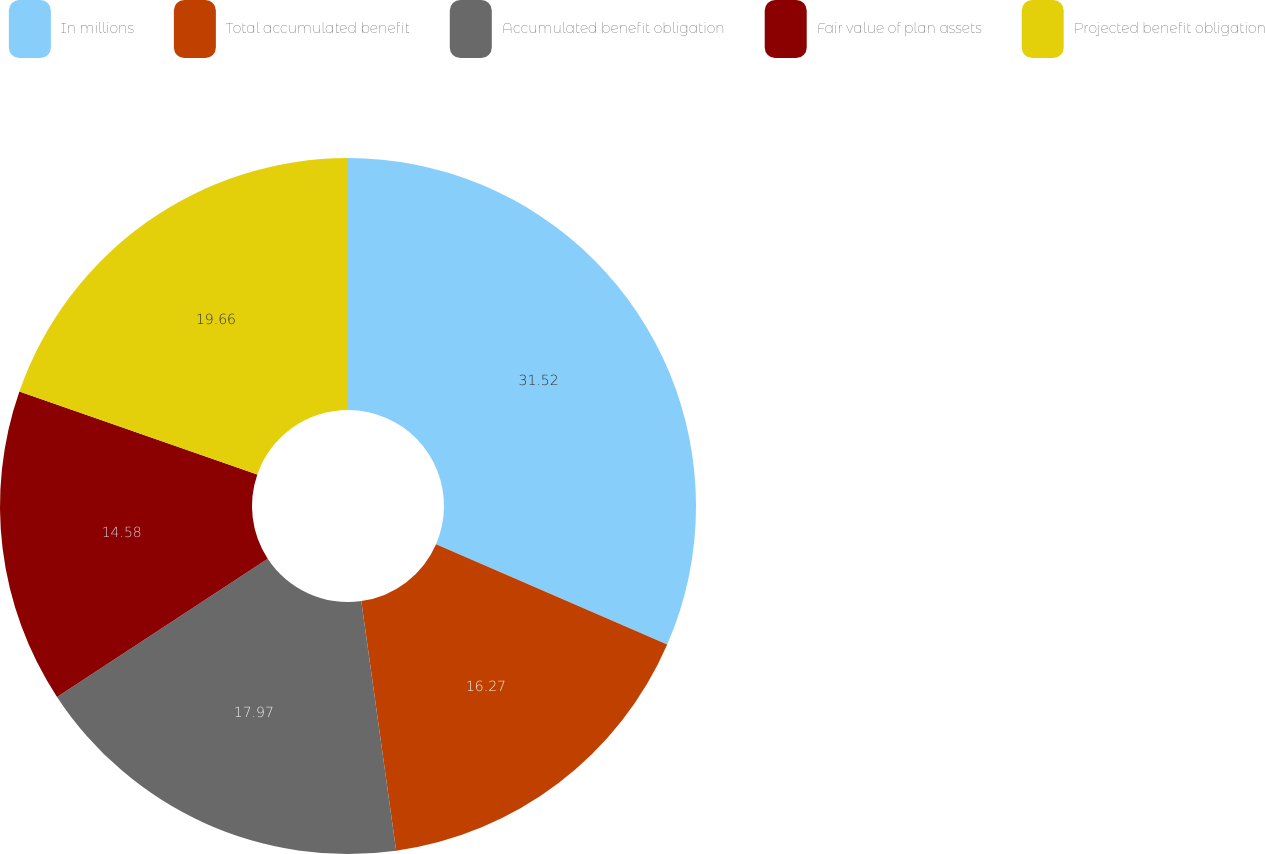<chart> <loc_0><loc_0><loc_500><loc_500><pie_chart><fcel>In millions<fcel>Total accumulated benefit<fcel>Accumulated benefit obligation<fcel>Fair value of plan assets<fcel>Projected benefit obligation<nl><fcel>31.52%<fcel>16.27%<fcel>17.97%<fcel>14.58%<fcel>19.66%<nl></chart> 